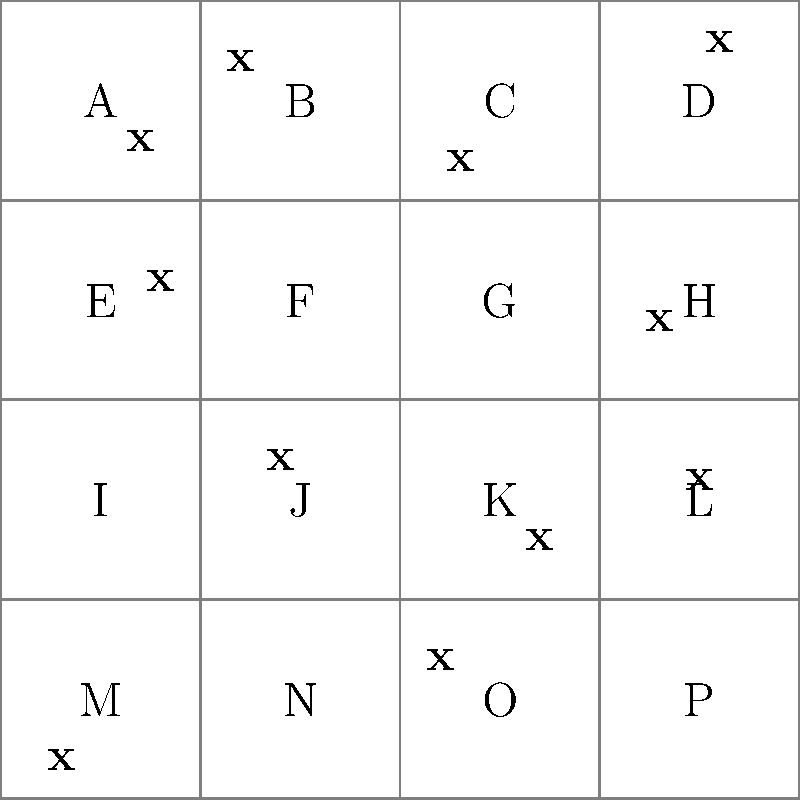As a seasoned angler, you've been asked to help estimate the fish population in Old Mill Lake. The lake has been divided into 16 equal quadrants, labeled A through P. Fish sightings are marked with an 'x'. If each quadrant represents 1 acre, what's the estimated fish population density per acre for the entire lake? Let's approach this the old-fashioned way, using simple counting and arithmetic:

1. Count the total number of fish sightings (x's) in the lake:
   There are 11 fish sightings in total.

2. Count the number of quadrants:
   There are 16 quadrants (A through P).

3. Calculate the average number of fish per quadrant:
   Average fish per quadrant = Total fish ÷ Total quadrants
   $$ \frac{11 \text{ fish}}{16 \text{ quadrants}} = 0.6875 \text{ fish per quadrant} $$

4. Since each quadrant represents 1 acre, this average is also the fish density per acre.

5. To express this as a whole number, we can say there are approximately 69 fish per 100 acres:
   $$ 0.6875 \times 100 = 68.75 \approx 69 \text{ fish per 100 acres} $$

This method gives us a rough estimate of the fish population density across the entire lake, assuming the sample is representative.
Answer: 69 fish per 100 acres 